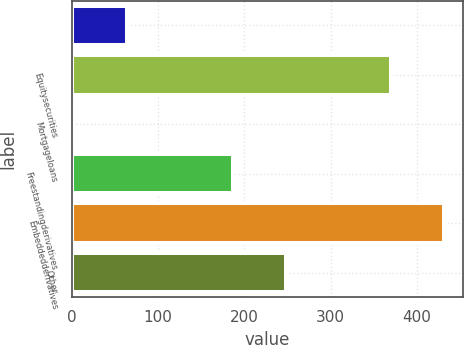Convert chart. <chart><loc_0><loc_0><loc_500><loc_500><bar_chart><ecel><fcel>Equitysecurities<fcel>Mortgageloans<fcel>Freestandingderivatives<fcel>Embeddedderivatives<fcel>Other<nl><fcel>64.2<fcel>370.2<fcel>3<fcel>186.6<fcel>431.4<fcel>247.8<nl></chart> 